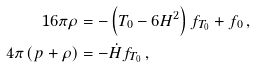<formula> <loc_0><loc_0><loc_500><loc_500>1 6 \pi \rho & = - \left ( T _ { 0 } - 6 H ^ { 2 } \right ) f _ { T _ { 0 } } + f _ { 0 } \, , \\ 4 \pi \, ( p + \rho ) & = - \dot { H } f _ { T _ { 0 } } \, ,</formula> 